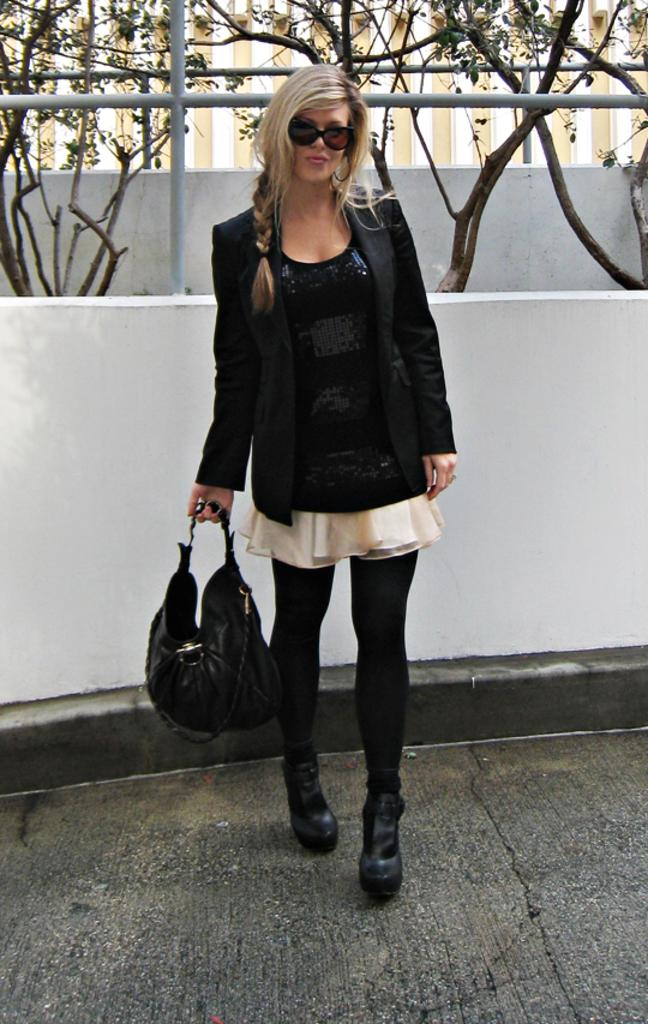Who is present in the image? There is a woman in the image. What is the woman doing in the image? The woman is standing in the image. What object is the woman holding in her hand? The woman is holding a handbag in her hand. What can be seen in the background of the image? There are plants visible behind the woman. What type of steel is the squirrel made of in the image? There is no squirrel present in the image, and therefore no material can be attributed to it. 